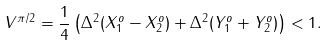<formula> <loc_0><loc_0><loc_500><loc_500>V ^ { \pi / 2 } = \frac { 1 } { 4 } \left ( \Delta ^ { 2 } ( X _ { 1 } ^ { o } - X _ { 2 } ^ { o } ) + \Delta ^ { 2 } ( Y _ { 1 } ^ { o } + Y _ { 2 } ^ { o } ) \right ) < 1 .</formula> 